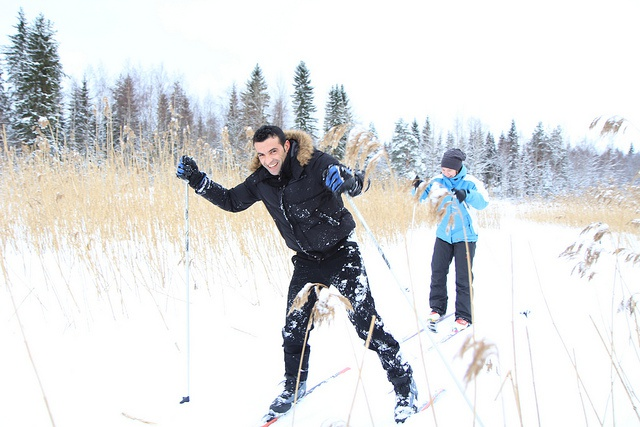Describe the objects in this image and their specific colors. I can see people in white, black, and gray tones, people in white, gray, and lightblue tones, skis in white, darkgray, lightblue, and pink tones, and skis in white, darkgray, lightblue, and lavender tones in this image. 